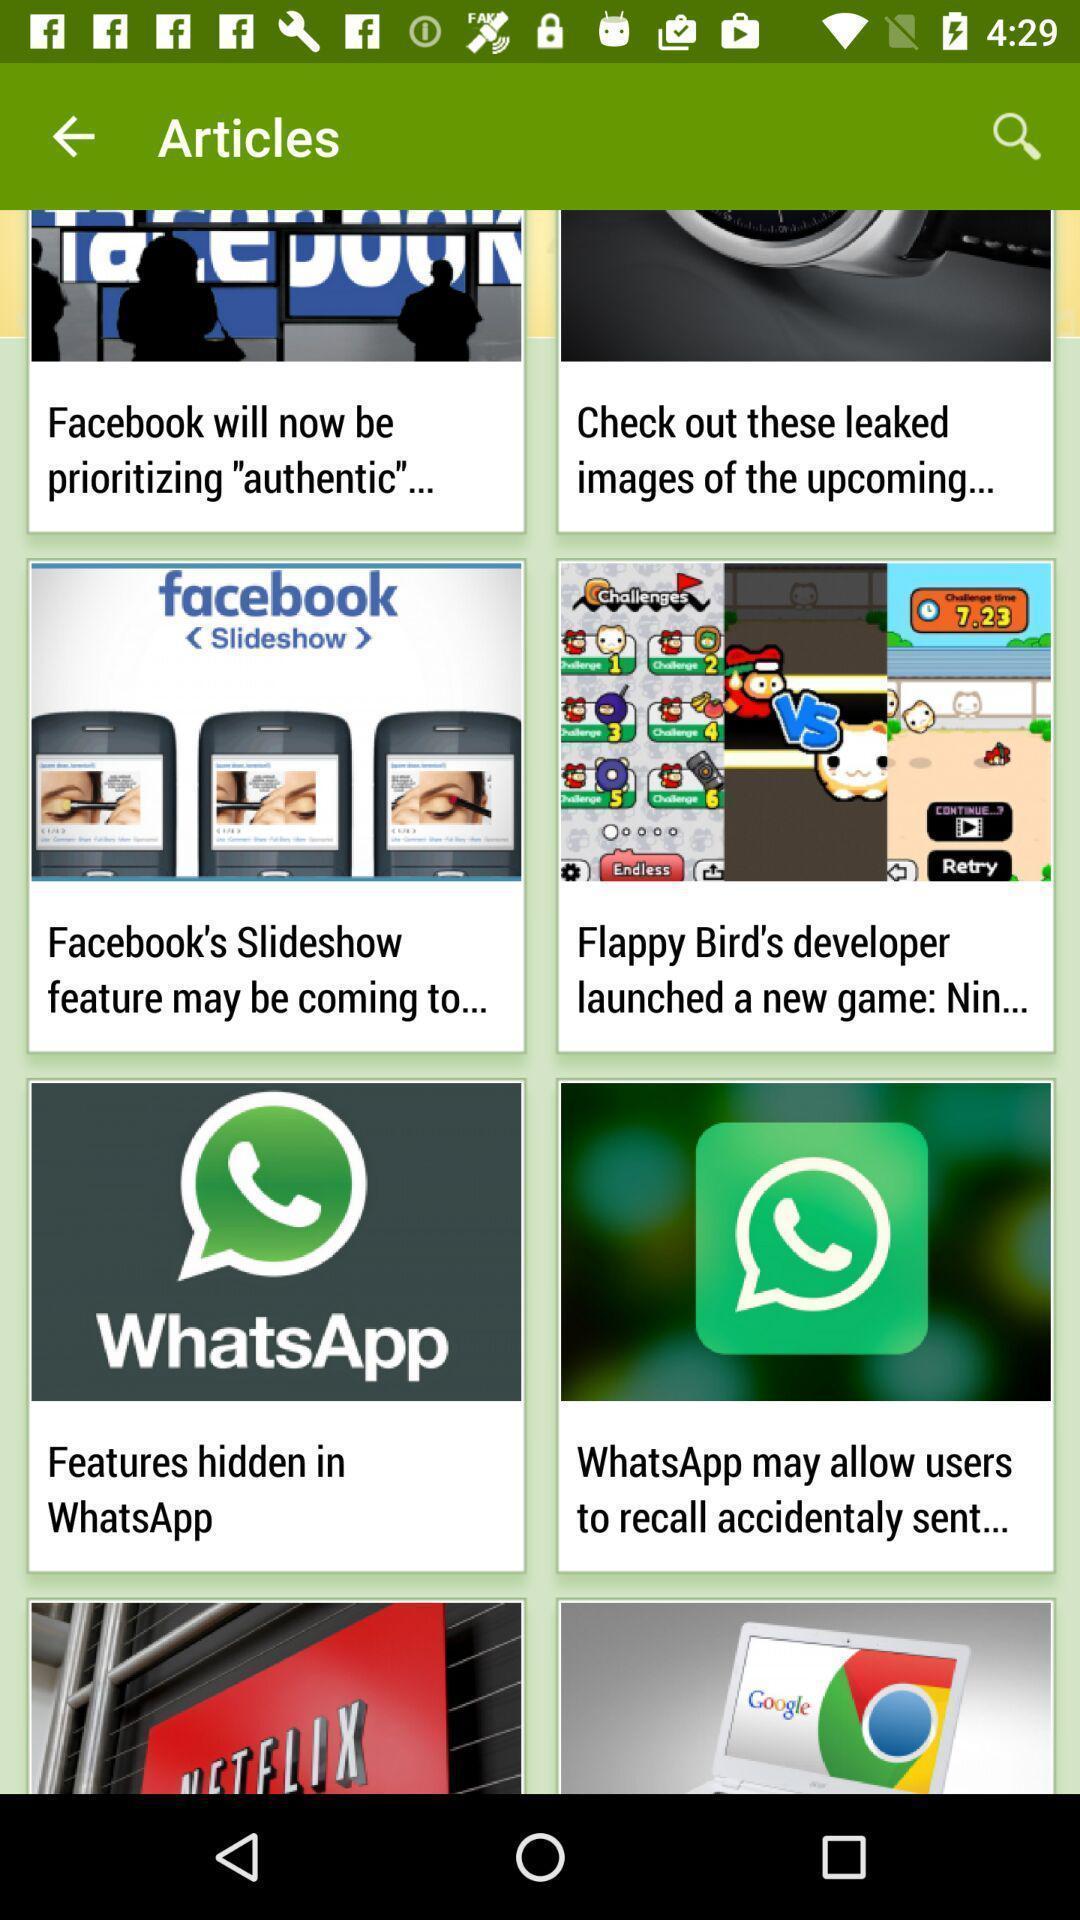Give me a summary of this screen capture. Social application articles showing in this page. 